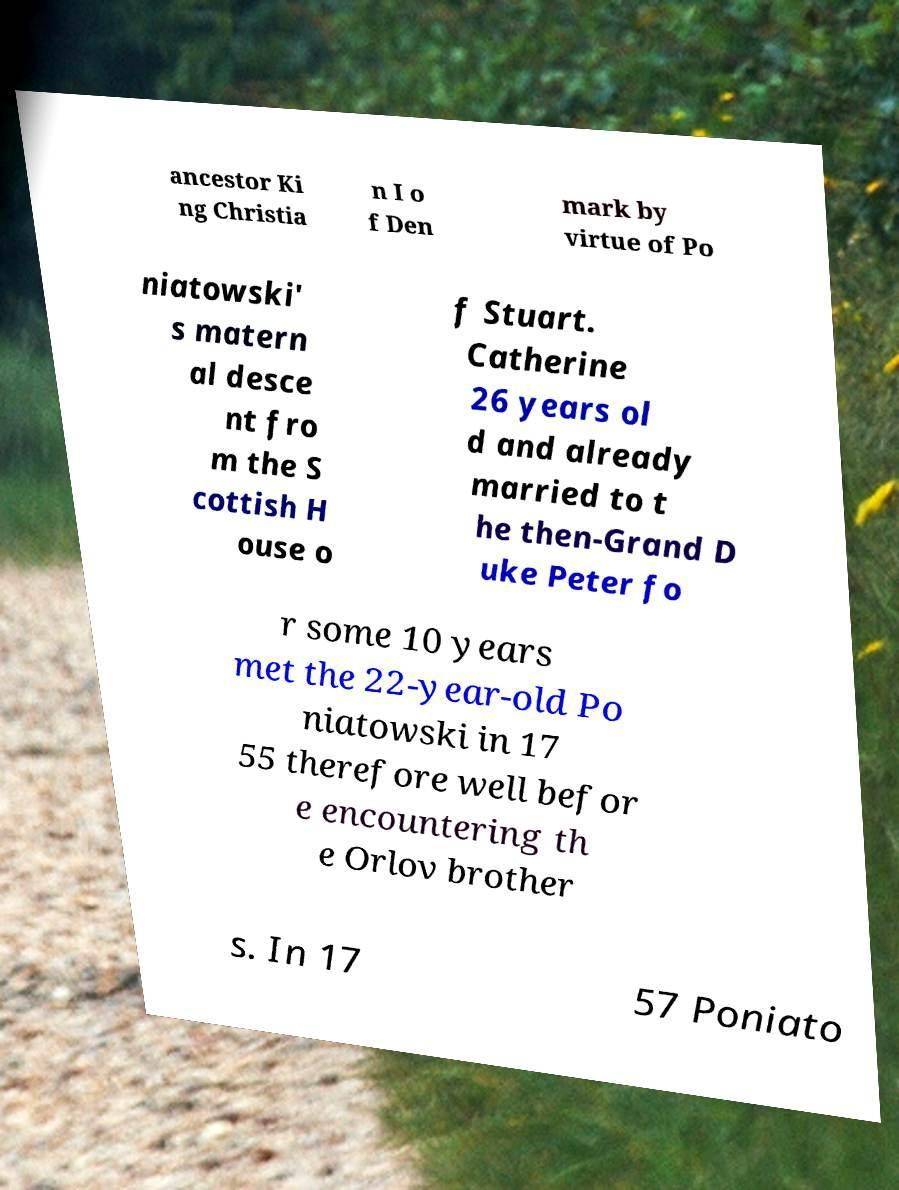Can you read and provide the text displayed in the image?This photo seems to have some interesting text. Can you extract and type it out for me? ancestor Ki ng Christia n I o f Den mark by virtue of Po niatowski' s matern al desce nt fro m the S cottish H ouse o f Stuart. Catherine 26 years ol d and already married to t he then-Grand D uke Peter fo r some 10 years met the 22-year-old Po niatowski in 17 55 therefore well befor e encountering th e Orlov brother s. In 17 57 Poniato 